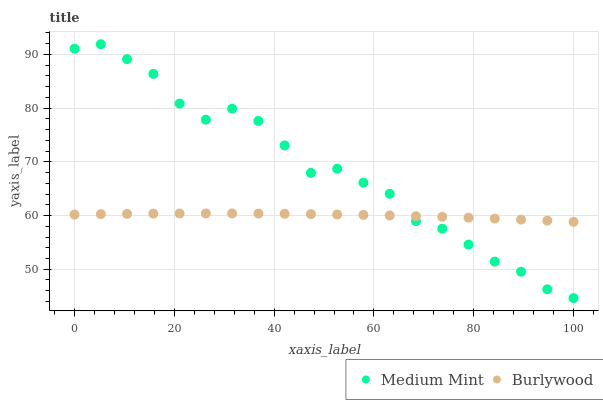Does Burlywood have the minimum area under the curve?
Answer yes or no. Yes. Does Medium Mint have the maximum area under the curve?
Answer yes or no. Yes. Does Burlywood have the maximum area under the curve?
Answer yes or no. No. Is Burlywood the smoothest?
Answer yes or no. Yes. Is Medium Mint the roughest?
Answer yes or no. Yes. Is Burlywood the roughest?
Answer yes or no. No. Does Medium Mint have the lowest value?
Answer yes or no. Yes. Does Burlywood have the lowest value?
Answer yes or no. No. Does Medium Mint have the highest value?
Answer yes or no. Yes. Does Burlywood have the highest value?
Answer yes or no. No. Does Medium Mint intersect Burlywood?
Answer yes or no. Yes. Is Medium Mint less than Burlywood?
Answer yes or no. No. Is Medium Mint greater than Burlywood?
Answer yes or no. No. 